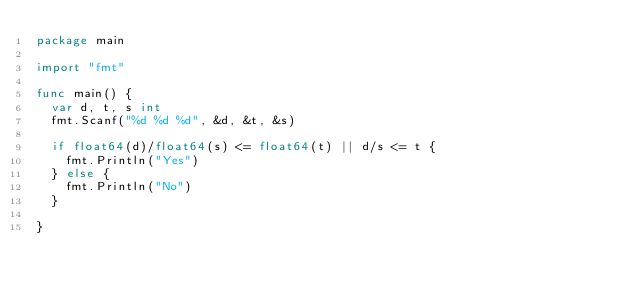<code> <loc_0><loc_0><loc_500><loc_500><_Go_>package main

import "fmt"

func main() {
	var d, t, s int
	fmt.Scanf("%d %d %d", &d, &t, &s)

	if float64(d)/float64(s) <= float64(t) || d/s <= t {
		fmt.Println("Yes")
	} else {
		fmt.Println("No")
	}

}
</code> 